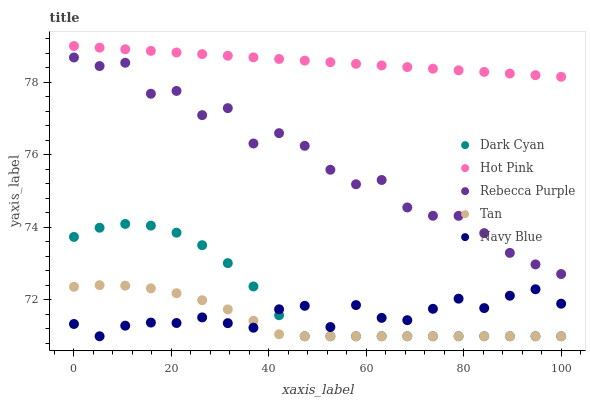Does Tan have the minimum area under the curve?
Answer yes or no. Yes. Does Hot Pink have the maximum area under the curve?
Answer yes or no. Yes. Does Navy Blue have the minimum area under the curve?
Answer yes or no. No. Does Navy Blue have the maximum area under the curve?
Answer yes or no. No. Is Hot Pink the smoothest?
Answer yes or no. Yes. Is Rebecca Purple the roughest?
Answer yes or no. Yes. Is Navy Blue the smoothest?
Answer yes or no. No. Is Navy Blue the roughest?
Answer yes or no. No. Does Dark Cyan have the lowest value?
Answer yes or no. Yes. Does Hot Pink have the lowest value?
Answer yes or no. No. Does Hot Pink have the highest value?
Answer yes or no. Yes. Does Tan have the highest value?
Answer yes or no. No. Is Rebecca Purple less than Hot Pink?
Answer yes or no. Yes. Is Rebecca Purple greater than Tan?
Answer yes or no. Yes. Does Dark Cyan intersect Tan?
Answer yes or no. Yes. Is Dark Cyan less than Tan?
Answer yes or no. No. Is Dark Cyan greater than Tan?
Answer yes or no. No. Does Rebecca Purple intersect Hot Pink?
Answer yes or no. No. 